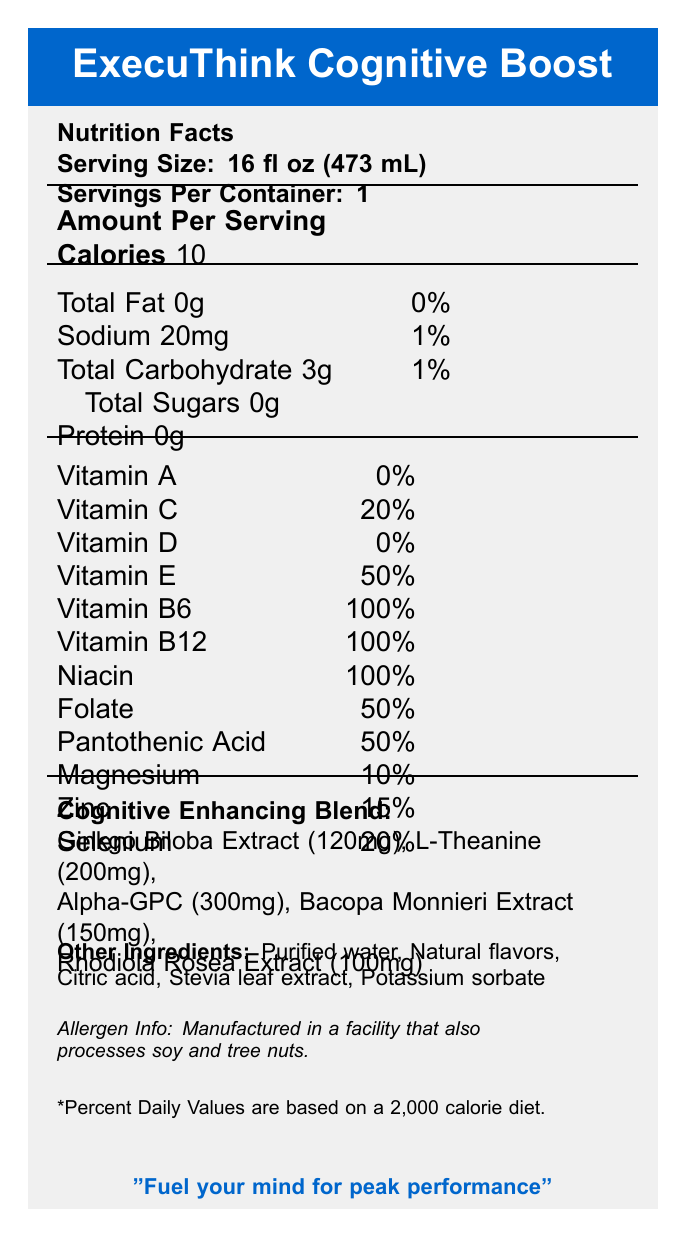What is the serving size of the ExecuThink Cognitive Boost? The serving size is listed near the top of the document as "Serving Size: 16 fl oz (473 mL)".
Answer: 16 fl oz (473 mL) How many calories does one serving of ExecuThink Cognitive Boost contain? The document specifies "Calories 10" under the "Amount Per Serving" section.
Answer: 10 What percentage of the daily value of Vitamin E is provided by ExecuThink Cognitive Boost? The percentage daily values for various vitamins and minerals are listed in the nutrition facts, showing "Vitamin E 50%".
Answer: 50% What is the total carbohydrate content per serving? Under "Amount Per Serving", it is stated "Total Carbohydrate 3g".
Answer: 3g What ingredient is listed first under the "Cognitive Enhancing Blend"? The Cognitive Enhancing Blend section lists "Ginkgo Biloba Extract (120mg)" first.
Answer: Ginkgo Biloba Extract What vitamins are present at 100% daily value in one serving? A. Vitamin C and Vitamin E B. Vitamin B6 and Vitamin B12 C. Niacin and Folate D. Magnesium and Zinc The nutrition facts show "Vitamin B6 100%" and "Vitamin B12 100%".
Answer: B. Vitamin B6 and Vitamin B12 Which of the following is NOT an ingredient in ExecuThink Cognitive Boost? A. Purified water B. Citric acid C. Sugar D. Stevia leaf extract The "Other Ingredients" list does not include sugar.
Answer: C. Sugar True or False: ExecuThink Cognitive Boost contains protein. The nutrition facts explicitly state "Protein 0g".
Answer: False Summarize the main features of ExecuThink Cognitive Boost described in the document. The summary captures the main elements including nutritional content, cognitive benefits, ingredient list, marketing claims, and Steve Rauschenberger's endorsement from the document.
Answer: ExecuThink Cognitive Boost is a vitamin-enriched water beverage designed to support cognitive function and decision-making skills. It contains a blend of vitamins, minerals, and cognitive-enhancing ingredients like Ginkgo Biloba Extract, L-Theanine, and Alpha-GPC. Each serving is 16 fl oz, contains 10 calories, and provides significant daily values of certain vitamins and minerals like Vitamin B6 and B12. The product is marketed as zero sugar and keto-friendly, with endorsements highlighting its benefits for mental clarity and focus during high-stakes business scenarios. What is the total amount of L-Theanine in ExecuThink Cognitive Boost? The Cognitive Enhancing Blend lists "L-Theanine (200mg)".
Answer: 200mg Which vitamin is NOT present in ExecuThink Cognitive Boost? The nutrition facts show "Vitamin D 0%".
Answer: Vitamin D How should ExecuThink Cognitive Boost be stored after opening? The storage instructions indicate to "Refrigerate after opening and consume within 3 days".
Answer: Refrigerate after opening and consume within 3 days Can ExecuThink Cognitive Boost help in diagnosing or curing diseases? The disclaimer in the document states, "This product is not intended to diagnose, treat, cure, or prevent any disease".
Answer: No How much selenium is in a single serving of ExecuThink Cognitive Boost? The nutrition facts show "Selenium 20%" under the % Daily Value column.
Answer: 20% Who endorses ExecuThink Cognitive Boost and mentions its benefits? The document includes a quote from Steve Rauschenberger endorsing the product.
Answer: Steve Rauschenberger Does ExecuThink Cognitive Boost contain any allergens? The allergen info notes that it is "Manufactured in a facility that also processes soy and tree nuts".
Answer: Manufactured in a facility that also processes soy and tree nuts What is the amount of Alpha-GPC in one serving? The Cognitive Enhancing Blend lists "Alpha-GPC (300mg)".
Answer: 300mg Is ExecuThink Cognitive Boost keto-friendly? The marketing claims prominently state "Zero sugar, keto-friendly formula".
Answer: Yes How often should you consume ExecuThink Cognitive Boost before a business meeting? The recommended use advises consuming one bottle "30 minutes before important meetings".
Answer: 30 minutes before How many servings are there in one container of ExecuThink Cognitive Boost? It is listed at the top of the document as "Servings Per Container: 1".
Answer: 1 What is the color code for the font used for the product name and branding in the document? The document itself does not visually specify the color code.
Answer: Cannot be determined 